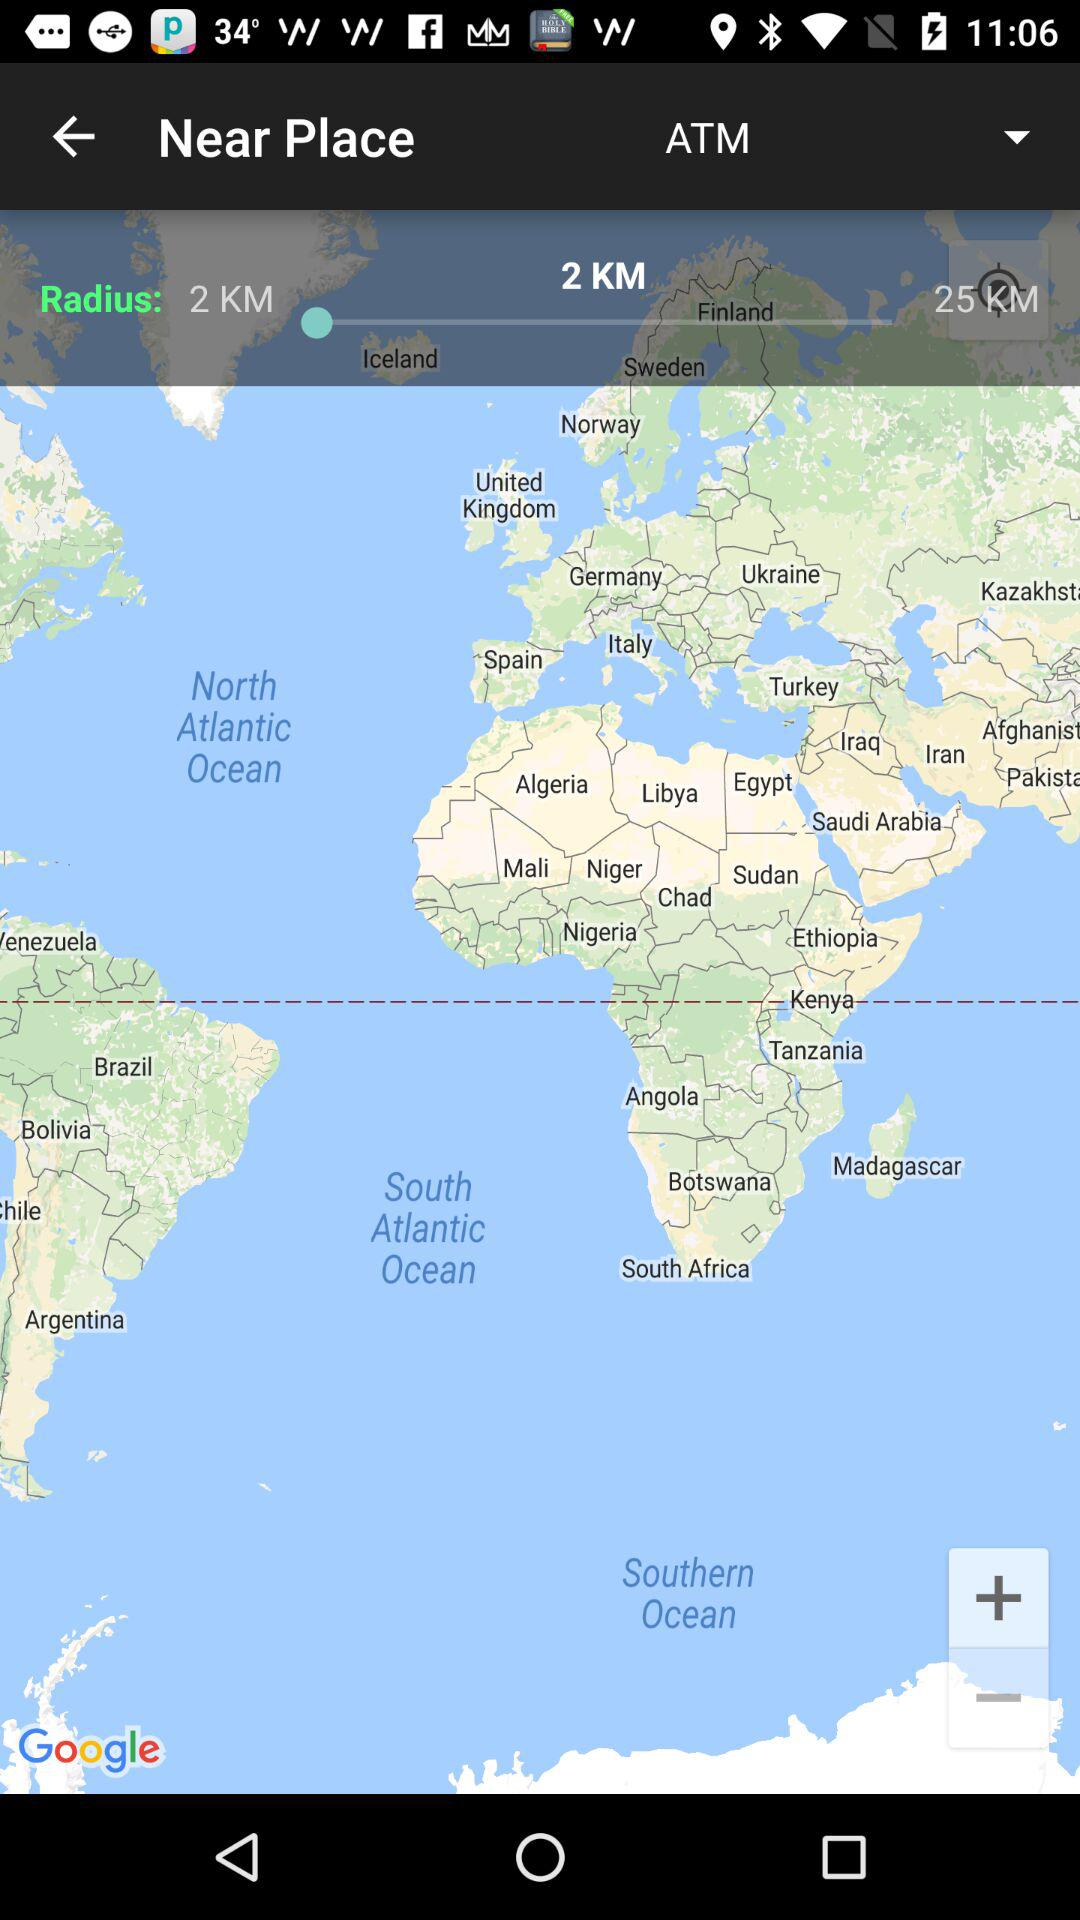How many more kilometers is the distance of 25 km than the distance of 2 km?
Answer the question using a single word or phrase. 23 